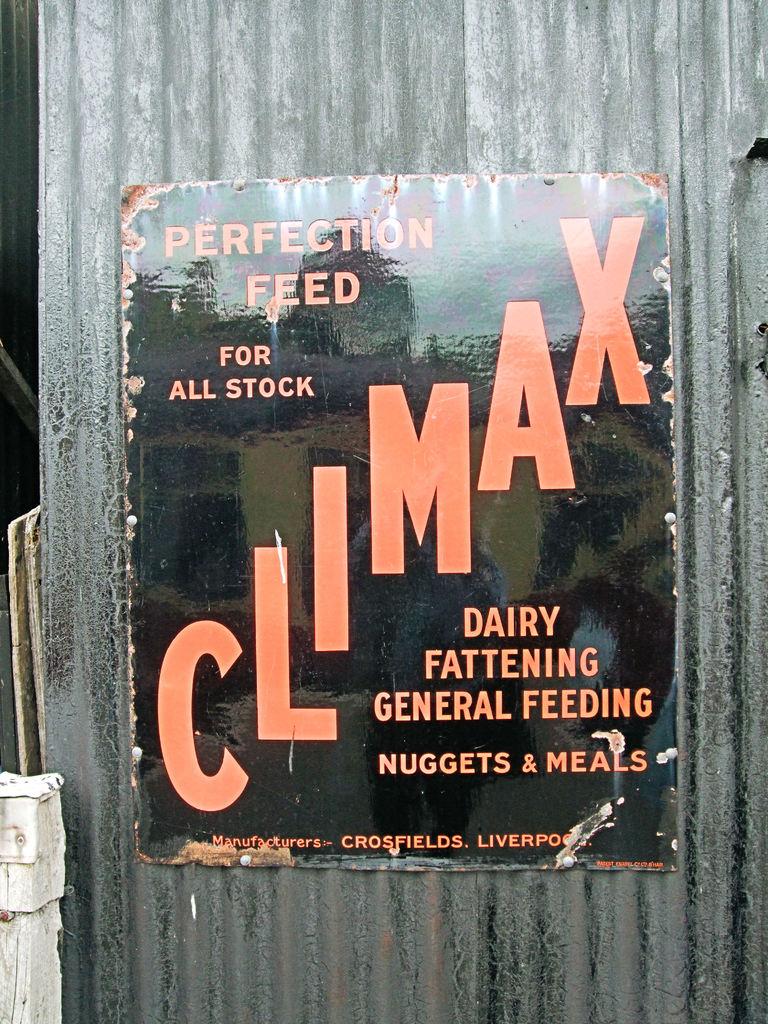What type of feeding is the sign for?
Keep it short and to the point. Perfection. 